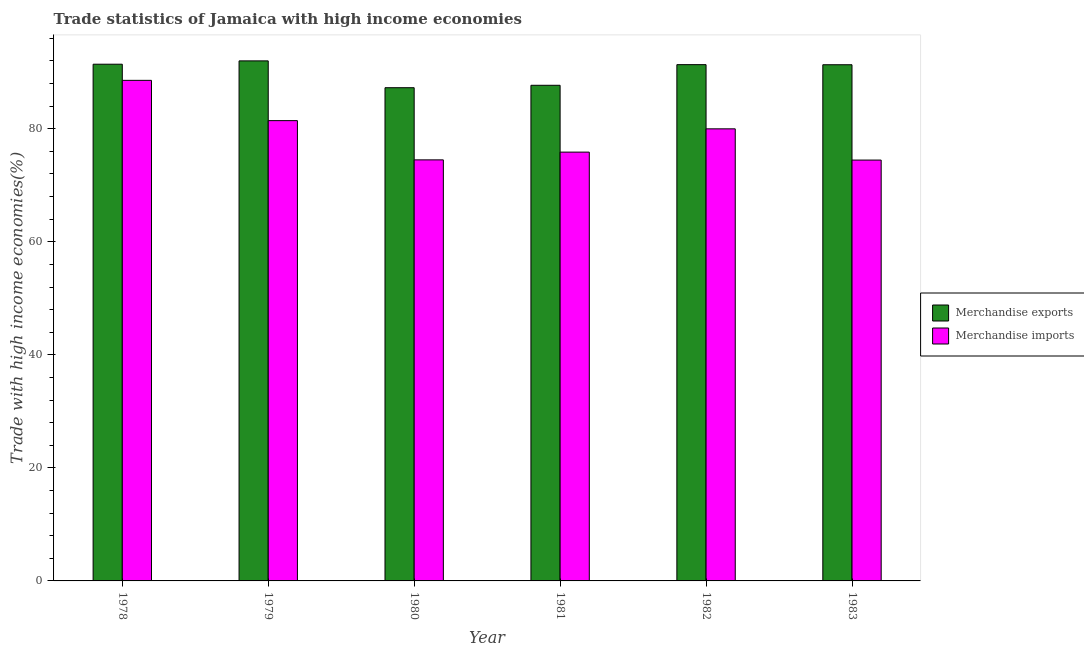How many different coloured bars are there?
Offer a very short reply. 2. Are the number of bars per tick equal to the number of legend labels?
Ensure brevity in your answer.  Yes. How many bars are there on the 2nd tick from the right?
Provide a short and direct response. 2. What is the label of the 2nd group of bars from the left?
Your response must be concise. 1979. In how many cases, is the number of bars for a given year not equal to the number of legend labels?
Provide a succinct answer. 0. What is the merchandise imports in 1982?
Provide a short and direct response. 79.99. Across all years, what is the maximum merchandise imports?
Your response must be concise. 88.57. Across all years, what is the minimum merchandise exports?
Your response must be concise. 87.27. In which year was the merchandise exports maximum?
Offer a very short reply. 1979. What is the total merchandise exports in the graph?
Your answer should be compact. 541.06. What is the difference between the merchandise imports in 1980 and that in 1982?
Provide a short and direct response. -5.49. What is the difference between the merchandise imports in 1979 and the merchandise exports in 1980?
Make the answer very short. 6.94. What is the average merchandise imports per year?
Offer a terse response. 79.14. In the year 1981, what is the difference between the merchandise imports and merchandise exports?
Provide a succinct answer. 0. What is the ratio of the merchandise exports in 1978 to that in 1980?
Offer a very short reply. 1.05. Is the merchandise exports in 1982 less than that in 1983?
Make the answer very short. No. What is the difference between the highest and the second highest merchandise exports?
Ensure brevity in your answer.  0.59. What is the difference between the highest and the lowest merchandise exports?
Give a very brief answer. 4.75. What does the 1st bar from the left in 1978 represents?
Your answer should be compact. Merchandise exports. What does the 1st bar from the right in 1978 represents?
Offer a terse response. Merchandise imports. How many bars are there?
Offer a very short reply. 12. How many years are there in the graph?
Offer a terse response. 6. What is the difference between two consecutive major ticks on the Y-axis?
Ensure brevity in your answer.  20. Are the values on the major ticks of Y-axis written in scientific E-notation?
Provide a succinct answer. No. Does the graph contain any zero values?
Keep it short and to the point. No. How are the legend labels stacked?
Your response must be concise. Vertical. What is the title of the graph?
Make the answer very short. Trade statistics of Jamaica with high income economies. Does "Investment" appear as one of the legend labels in the graph?
Provide a succinct answer. No. What is the label or title of the Y-axis?
Offer a very short reply. Trade with high income economies(%). What is the Trade with high income economies(%) in Merchandise exports in 1978?
Your response must be concise. 91.42. What is the Trade with high income economies(%) of Merchandise imports in 1978?
Give a very brief answer. 88.57. What is the Trade with high income economies(%) in Merchandise exports in 1979?
Keep it short and to the point. 92.01. What is the Trade with high income economies(%) of Merchandise imports in 1979?
Provide a succinct answer. 81.44. What is the Trade with high income economies(%) of Merchandise exports in 1980?
Make the answer very short. 87.27. What is the Trade with high income economies(%) in Merchandise imports in 1980?
Give a very brief answer. 74.5. What is the Trade with high income economies(%) of Merchandise exports in 1981?
Give a very brief answer. 87.69. What is the Trade with high income economies(%) of Merchandise imports in 1981?
Give a very brief answer. 75.87. What is the Trade with high income economies(%) of Merchandise exports in 1982?
Provide a short and direct response. 91.35. What is the Trade with high income economies(%) in Merchandise imports in 1982?
Ensure brevity in your answer.  79.99. What is the Trade with high income economies(%) in Merchandise exports in 1983?
Offer a terse response. 91.33. What is the Trade with high income economies(%) of Merchandise imports in 1983?
Your answer should be very brief. 74.46. Across all years, what is the maximum Trade with high income economies(%) of Merchandise exports?
Keep it short and to the point. 92.01. Across all years, what is the maximum Trade with high income economies(%) in Merchandise imports?
Provide a short and direct response. 88.57. Across all years, what is the minimum Trade with high income economies(%) of Merchandise exports?
Provide a succinct answer. 87.27. Across all years, what is the minimum Trade with high income economies(%) of Merchandise imports?
Offer a terse response. 74.46. What is the total Trade with high income economies(%) of Merchandise exports in the graph?
Ensure brevity in your answer.  541.06. What is the total Trade with high income economies(%) of Merchandise imports in the graph?
Your answer should be very brief. 474.82. What is the difference between the Trade with high income economies(%) of Merchandise exports in 1978 and that in 1979?
Provide a short and direct response. -0.59. What is the difference between the Trade with high income economies(%) of Merchandise imports in 1978 and that in 1979?
Your answer should be compact. 7.13. What is the difference between the Trade with high income economies(%) in Merchandise exports in 1978 and that in 1980?
Give a very brief answer. 4.16. What is the difference between the Trade with high income economies(%) of Merchandise imports in 1978 and that in 1980?
Provide a short and direct response. 14.07. What is the difference between the Trade with high income economies(%) of Merchandise exports in 1978 and that in 1981?
Ensure brevity in your answer.  3.73. What is the difference between the Trade with high income economies(%) in Merchandise imports in 1978 and that in 1981?
Provide a short and direct response. 12.7. What is the difference between the Trade with high income economies(%) in Merchandise exports in 1978 and that in 1982?
Provide a short and direct response. 0.08. What is the difference between the Trade with high income economies(%) in Merchandise imports in 1978 and that in 1982?
Your response must be concise. 8.58. What is the difference between the Trade with high income economies(%) in Merchandise exports in 1978 and that in 1983?
Give a very brief answer. 0.1. What is the difference between the Trade with high income economies(%) of Merchandise imports in 1978 and that in 1983?
Offer a terse response. 14.1. What is the difference between the Trade with high income economies(%) in Merchandise exports in 1979 and that in 1980?
Your response must be concise. 4.75. What is the difference between the Trade with high income economies(%) in Merchandise imports in 1979 and that in 1980?
Provide a short and direct response. 6.94. What is the difference between the Trade with high income economies(%) of Merchandise exports in 1979 and that in 1981?
Offer a very short reply. 4.32. What is the difference between the Trade with high income economies(%) in Merchandise imports in 1979 and that in 1981?
Your answer should be very brief. 5.57. What is the difference between the Trade with high income economies(%) of Merchandise exports in 1979 and that in 1982?
Provide a succinct answer. 0.67. What is the difference between the Trade with high income economies(%) in Merchandise imports in 1979 and that in 1982?
Ensure brevity in your answer.  1.45. What is the difference between the Trade with high income economies(%) in Merchandise exports in 1979 and that in 1983?
Provide a succinct answer. 0.68. What is the difference between the Trade with high income economies(%) of Merchandise imports in 1979 and that in 1983?
Provide a succinct answer. 6.98. What is the difference between the Trade with high income economies(%) in Merchandise exports in 1980 and that in 1981?
Make the answer very short. -0.43. What is the difference between the Trade with high income economies(%) in Merchandise imports in 1980 and that in 1981?
Your answer should be very brief. -1.37. What is the difference between the Trade with high income economies(%) in Merchandise exports in 1980 and that in 1982?
Your answer should be compact. -4.08. What is the difference between the Trade with high income economies(%) in Merchandise imports in 1980 and that in 1982?
Provide a succinct answer. -5.49. What is the difference between the Trade with high income economies(%) in Merchandise exports in 1980 and that in 1983?
Ensure brevity in your answer.  -4.06. What is the difference between the Trade with high income economies(%) in Merchandise imports in 1980 and that in 1983?
Offer a very short reply. 0.04. What is the difference between the Trade with high income economies(%) in Merchandise exports in 1981 and that in 1982?
Offer a terse response. -3.65. What is the difference between the Trade with high income economies(%) of Merchandise imports in 1981 and that in 1982?
Offer a very short reply. -4.12. What is the difference between the Trade with high income economies(%) in Merchandise exports in 1981 and that in 1983?
Your answer should be compact. -3.64. What is the difference between the Trade with high income economies(%) in Merchandise imports in 1981 and that in 1983?
Offer a very short reply. 1.41. What is the difference between the Trade with high income economies(%) in Merchandise exports in 1982 and that in 1983?
Ensure brevity in your answer.  0.02. What is the difference between the Trade with high income economies(%) in Merchandise imports in 1982 and that in 1983?
Offer a very short reply. 5.52. What is the difference between the Trade with high income economies(%) of Merchandise exports in 1978 and the Trade with high income economies(%) of Merchandise imports in 1979?
Provide a succinct answer. 9.98. What is the difference between the Trade with high income economies(%) in Merchandise exports in 1978 and the Trade with high income economies(%) in Merchandise imports in 1980?
Make the answer very short. 16.92. What is the difference between the Trade with high income economies(%) in Merchandise exports in 1978 and the Trade with high income economies(%) in Merchandise imports in 1981?
Make the answer very short. 15.55. What is the difference between the Trade with high income economies(%) in Merchandise exports in 1978 and the Trade with high income economies(%) in Merchandise imports in 1982?
Give a very brief answer. 11.44. What is the difference between the Trade with high income economies(%) in Merchandise exports in 1978 and the Trade with high income economies(%) in Merchandise imports in 1983?
Your answer should be very brief. 16.96. What is the difference between the Trade with high income economies(%) of Merchandise exports in 1979 and the Trade with high income economies(%) of Merchandise imports in 1980?
Make the answer very short. 17.51. What is the difference between the Trade with high income economies(%) in Merchandise exports in 1979 and the Trade with high income economies(%) in Merchandise imports in 1981?
Your response must be concise. 16.14. What is the difference between the Trade with high income economies(%) of Merchandise exports in 1979 and the Trade with high income economies(%) of Merchandise imports in 1982?
Provide a short and direct response. 12.02. What is the difference between the Trade with high income economies(%) of Merchandise exports in 1979 and the Trade with high income economies(%) of Merchandise imports in 1983?
Keep it short and to the point. 17.55. What is the difference between the Trade with high income economies(%) of Merchandise exports in 1980 and the Trade with high income economies(%) of Merchandise imports in 1981?
Your answer should be very brief. 11.4. What is the difference between the Trade with high income economies(%) in Merchandise exports in 1980 and the Trade with high income economies(%) in Merchandise imports in 1982?
Ensure brevity in your answer.  7.28. What is the difference between the Trade with high income economies(%) of Merchandise exports in 1980 and the Trade with high income economies(%) of Merchandise imports in 1983?
Ensure brevity in your answer.  12.8. What is the difference between the Trade with high income economies(%) of Merchandise exports in 1981 and the Trade with high income economies(%) of Merchandise imports in 1982?
Your response must be concise. 7.7. What is the difference between the Trade with high income economies(%) of Merchandise exports in 1981 and the Trade with high income economies(%) of Merchandise imports in 1983?
Give a very brief answer. 13.23. What is the difference between the Trade with high income economies(%) in Merchandise exports in 1982 and the Trade with high income economies(%) in Merchandise imports in 1983?
Provide a succinct answer. 16.88. What is the average Trade with high income economies(%) of Merchandise exports per year?
Your answer should be compact. 90.18. What is the average Trade with high income economies(%) of Merchandise imports per year?
Ensure brevity in your answer.  79.14. In the year 1978, what is the difference between the Trade with high income economies(%) of Merchandise exports and Trade with high income economies(%) of Merchandise imports?
Ensure brevity in your answer.  2.86. In the year 1979, what is the difference between the Trade with high income economies(%) in Merchandise exports and Trade with high income economies(%) in Merchandise imports?
Provide a succinct answer. 10.57. In the year 1980, what is the difference between the Trade with high income economies(%) of Merchandise exports and Trade with high income economies(%) of Merchandise imports?
Ensure brevity in your answer.  12.77. In the year 1981, what is the difference between the Trade with high income economies(%) in Merchandise exports and Trade with high income economies(%) in Merchandise imports?
Your answer should be compact. 11.82. In the year 1982, what is the difference between the Trade with high income economies(%) in Merchandise exports and Trade with high income economies(%) in Merchandise imports?
Make the answer very short. 11.36. In the year 1983, what is the difference between the Trade with high income economies(%) of Merchandise exports and Trade with high income economies(%) of Merchandise imports?
Your answer should be very brief. 16.86. What is the ratio of the Trade with high income economies(%) in Merchandise exports in 1978 to that in 1979?
Give a very brief answer. 0.99. What is the ratio of the Trade with high income economies(%) of Merchandise imports in 1978 to that in 1979?
Make the answer very short. 1.09. What is the ratio of the Trade with high income economies(%) of Merchandise exports in 1978 to that in 1980?
Provide a succinct answer. 1.05. What is the ratio of the Trade with high income economies(%) in Merchandise imports in 1978 to that in 1980?
Provide a succinct answer. 1.19. What is the ratio of the Trade with high income economies(%) of Merchandise exports in 1978 to that in 1981?
Provide a short and direct response. 1.04. What is the ratio of the Trade with high income economies(%) of Merchandise imports in 1978 to that in 1981?
Your response must be concise. 1.17. What is the ratio of the Trade with high income economies(%) in Merchandise imports in 1978 to that in 1982?
Keep it short and to the point. 1.11. What is the ratio of the Trade with high income economies(%) of Merchandise imports in 1978 to that in 1983?
Offer a terse response. 1.19. What is the ratio of the Trade with high income economies(%) in Merchandise exports in 1979 to that in 1980?
Offer a terse response. 1.05. What is the ratio of the Trade with high income economies(%) in Merchandise imports in 1979 to that in 1980?
Offer a terse response. 1.09. What is the ratio of the Trade with high income economies(%) of Merchandise exports in 1979 to that in 1981?
Provide a succinct answer. 1.05. What is the ratio of the Trade with high income economies(%) in Merchandise imports in 1979 to that in 1981?
Offer a terse response. 1.07. What is the ratio of the Trade with high income economies(%) in Merchandise exports in 1979 to that in 1982?
Your answer should be compact. 1.01. What is the ratio of the Trade with high income economies(%) in Merchandise imports in 1979 to that in 1982?
Provide a short and direct response. 1.02. What is the ratio of the Trade with high income economies(%) in Merchandise exports in 1979 to that in 1983?
Make the answer very short. 1.01. What is the ratio of the Trade with high income economies(%) in Merchandise imports in 1979 to that in 1983?
Your answer should be compact. 1.09. What is the ratio of the Trade with high income economies(%) of Merchandise exports in 1980 to that in 1981?
Offer a terse response. 1. What is the ratio of the Trade with high income economies(%) of Merchandise imports in 1980 to that in 1981?
Ensure brevity in your answer.  0.98. What is the ratio of the Trade with high income economies(%) in Merchandise exports in 1980 to that in 1982?
Keep it short and to the point. 0.96. What is the ratio of the Trade with high income economies(%) in Merchandise imports in 1980 to that in 1982?
Give a very brief answer. 0.93. What is the ratio of the Trade with high income economies(%) of Merchandise exports in 1980 to that in 1983?
Give a very brief answer. 0.96. What is the ratio of the Trade with high income economies(%) of Merchandise imports in 1980 to that in 1983?
Keep it short and to the point. 1. What is the ratio of the Trade with high income economies(%) in Merchandise exports in 1981 to that in 1982?
Provide a succinct answer. 0.96. What is the ratio of the Trade with high income economies(%) of Merchandise imports in 1981 to that in 1982?
Your response must be concise. 0.95. What is the ratio of the Trade with high income economies(%) of Merchandise exports in 1981 to that in 1983?
Give a very brief answer. 0.96. What is the ratio of the Trade with high income economies(%) of Merchandise imports in 1981 to that in 1983?
Provide a short and direct response. 1.02. What is the ratio of the Trade with high income economies(%) in Merchandise exports in 1982 to that in 1983?
Keep it short and to the point. 1. What is the ratio of the Trade with high income economies(%) in Merchandise imports in 1982 to that in 1983?
Give a very brief answer. 1.07. What is the difference between the highest and the second highest Trade with high income economies(%) in Merchandise exports?
Keep it short and to the point. 0.59. What is the difference between the highest and the second highest Trade with high income economies(%) of Merchandise imports?
Give a very brief answer. 7.13. What is the difference between the highest and the lowest Trade with high income economies(%) in Merchandise exports?
Provide a short and direct response. 4.75. What is the difference between the highest and the lowest Trade with high income economies(%) in Merchandise imports?
Your answer should be very brief. 14.1. 